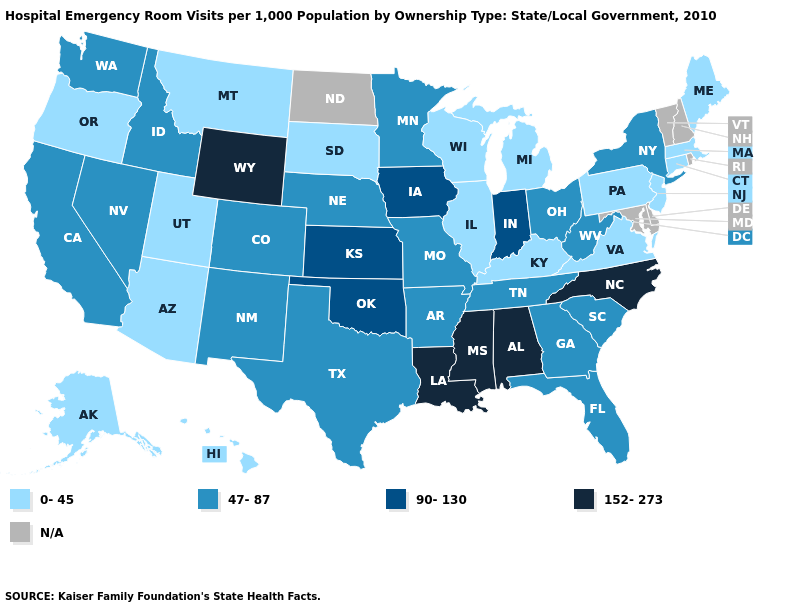What is the highest value in the Northeast ?
Short answer required. 47-87. Does Illinois have the lowest value in the MidWest?
Keep it brief. Yes. What is the highest value in the West ?
Quick response, please. 152-273. Among the states that border Georgia , which have the lowest value?
Write a very short answer. Florida, South Carolina, Tennessee. What is the highest value in the USA?
Concise answer only. 152-273. Is the legend a continuous bar?
Answer briefly. No. Among the states that border Iowa , does Wisconsin have the lowest value?
Be succinct. Yes. Does Kansas have the highest value in the MidWest?
Quick response, please. Yes. Among the states that border Washington , which have the lowest value?
Keep it brief. Oregon. What is the highest value in the USA?
Write a very short answer. 152-273. Does the map have missing data?
Short answer required. Yes. What is the lowest value in the West?
Give a very brief answer. 0-45. Does Oregon have the lowest value in the West?
Short answer required. Yes. Among the states that border Iowa , which have the lowest value?
Keep it brief. Illinois, South Dakota, Wisconsin. 